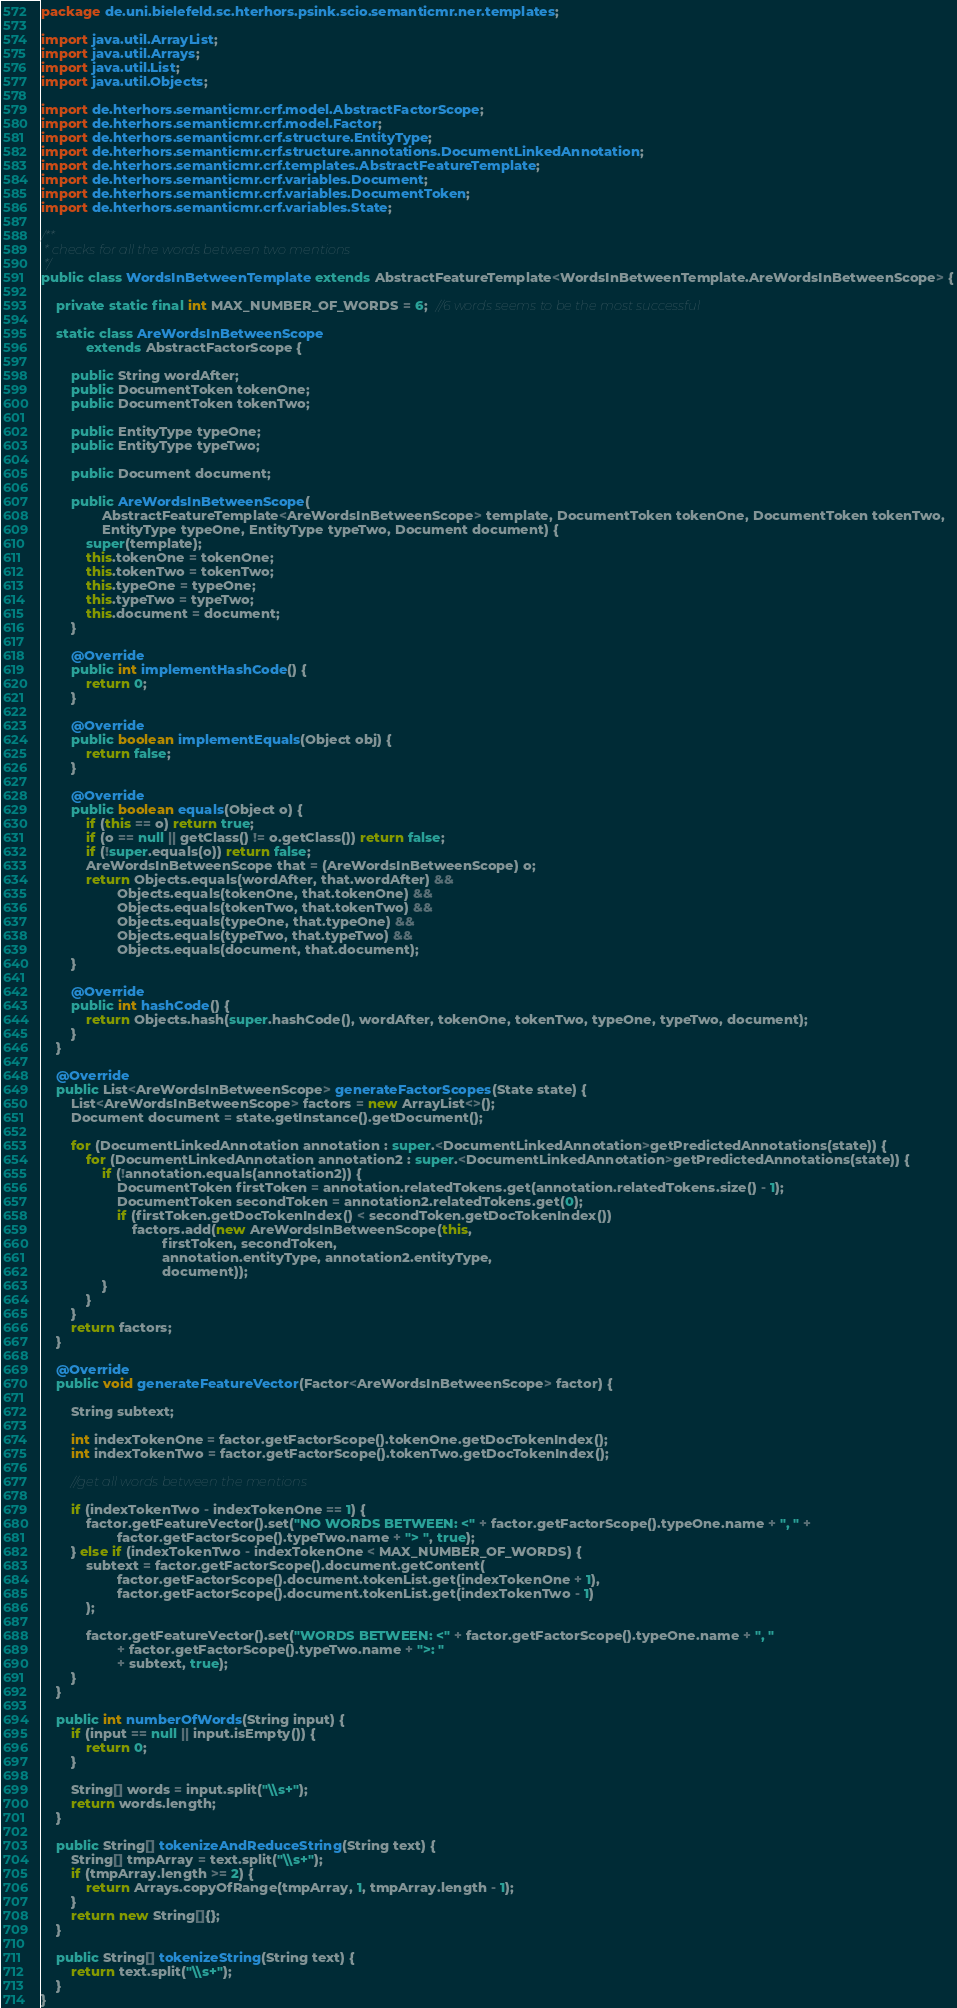<code> <loc_0><loc_0><loc_500><loc_500><_Java_>package de.uni.bielefeld.sc.hterhors.psink.scio.semanticmr.ner.templates;

import java.util.ArrayList;
import java.util.Arrays;
import java.util.List;
import java.util.Objects;

import de.hterhors.semanticmr.crf.model.AbstractFactorScope;
import de.hterhors.semanticmr.crf.model.Factor;
import de.hterhors.semanticmr.crf.structure.EntityType;
import de.hterhors.semanticmr.crf.structure.annotations.DocumentLinkedAnnotation;
import de.hterhors.semanticmr.crf.templates.AbstractFeatureTemplate;
import de.hterhors.semanticmr.crf.variables.Document;
import de.hterhors.semanticmr.crf.variables.DocumentToken;
import de.hterhors.semanticmr.crf.variables.State;

/**
 * checks for all the words between two mentions
 */
public class WordsInBetweenTemplate extends AbstractFeatureTemplate<WordsInBetweenTemplate.AreWordsInBetweenScope> {

    private static final int MAX_NUMBER_OF_WORDS = 6;  //6 words seems to be the most successful

    static class AreWordsInBetweenScope
            extends AbstractFactorScope {

        public String wordAfter;
        public DocumentToken tokenOne;
        public DocumentToken tokenTwo;

        public EntityType typeOne;
        public EntityType typeTwo;

        public Document document;

        public AreWordsInBetweenScope(
                AbstractFeatureTemplate<AreWordsInBetweenScope> template, DocumentToken tokenOne, DocumentToken tokenTwo,
                EntityType typeOne, EntityType typeTwo, Document document) {
            super(template);
            this.tokenOne = tokenOne;
            this.tokenTwo = tokenTwo;
            this.typeOne = typeOne;
            this.typeTwo = typeTwo;
            this.document = document;
        }

        @Override
        public int implementHashCode() {
            return 0;
        }

        @Override
        public boolean implementEquals(Object obj) {
            return false;
        }

        @Override
        public boolean equals(Object o) {
            if (this == o) return true;
            if (o == null || getClass() != o.getClass()) return false;
            if (!super.equals(o)) return false;
            AreWordsInBetweenScope that = (AreWordsInBetweenScope) o;
            return Objects.equals(wordAfter, that.wordAfter) &&
                    Objects.equals(tokenOne, that.tokenOne) &&
                    Objects.equals(tokenTwo, that.tokenTwo) &&
                    Objects.equals(typeOne, that.typeOne) &&
                    Objects.equals(typeTwo, that.typeTwo) &&
                    Objects.equals(document, that.document);
        }

        @Override
        public int hashCode() {
            return Objects.hash(super.hashCode(), wordAfter, tokenOne, tokenTwo, typeOne, typeTwo, document);
        }
    }

    @Override
    public List<AreWordsInBetweenScope> generateFactorScopes(State state) {
        List<AreWordsInBetweenScope> factors = new ArrayList<>();
        Document document = state.getInstance().getDocument();

        for (DocumentLinkedAnnotation annotation : super.<DocumentLinkedAnnotation>getPredictedAnnotations(state)) {
            for (DocumentLinkedAnnotation annotation2 : super.<DocumentLinkedAnnotation>getPredictedAnnotations(state)) {
                if (!annotation.equals(annotation2)) {
                    DocumentToken firstToken = annotation.relatedTokens.get(annotation.relatedTokens.size() - 1);
                    DocumentToken secondToken = annotation2.relatedTokens.get(0);
                    if (firstToken.getDocTokenIndex() < secondToken.getDocTokenIndex())
                        factors.add(new AreWordsInBetweenScope(this,
                                firstToken, secondToken,
                                annotation.entityType, annotation2.entityType,
                                document));
                }
            }
        }
        return factors;
    }

    @Override
    public void generateFeatureVector(Factor<AreWordsInBetweenScope> factor) {

        String subtext;

        int indexTokenOne = factor.getFactorScope().tokenOne.getDocTokenIndex();
        int indexTokenTwo = factor.getFactorScope().tokenTwo.getDocTokenIndex();

        //get all words between the mentions

        if (indexTokenTwo - indexTokenOne == 1) {
            factor.getFeatureVector().set("NO WORDS BETWEEN: <" + factor.getFactorScope().typeOne.name + ", " +
                    factor.getFactorScope().typeTwo.name + "> ", true);
        } else if (indexTokenTwo - indexTokenOne < MAX_NUMBER_OF_WORDS) {
            subtext = factor.getFactorScope().document.getContent(
                    factor.getFactorScope().document.tokenList.get(indexTokenOne + 1),
                    factor.getFactorScope().document.tokenList.get(indexTokenTwo - 1)
            );

            factor.getFeatureVector().set("WORDS BETWEEN: <" + factor.getFactorScope().typeOne.name + ", "
                    + factor.getFactorScope().typeTwo.name + ">: "
                    + subtext, true);
        }
    }

    public int numberOfWords(String input) {
        if (input == null || input.isEmpty()) {
            return 0;
        }

        String[] words = input.split("\\s+");
        return words.length;
    }

    public String[] tokenizeAndReduceString(String text) {
        String[] tmpArray = text.split("\\s+");
        if (tmpArray.length >= 2) {
            return Arrays.copyOfRange(tmpArray, 1, tmpArray.length - 1);
        }
        return new String[]{};
    }

    public String[] tokenizeString(String text) {
        return text.split("\\s+");
    }
}</code> 